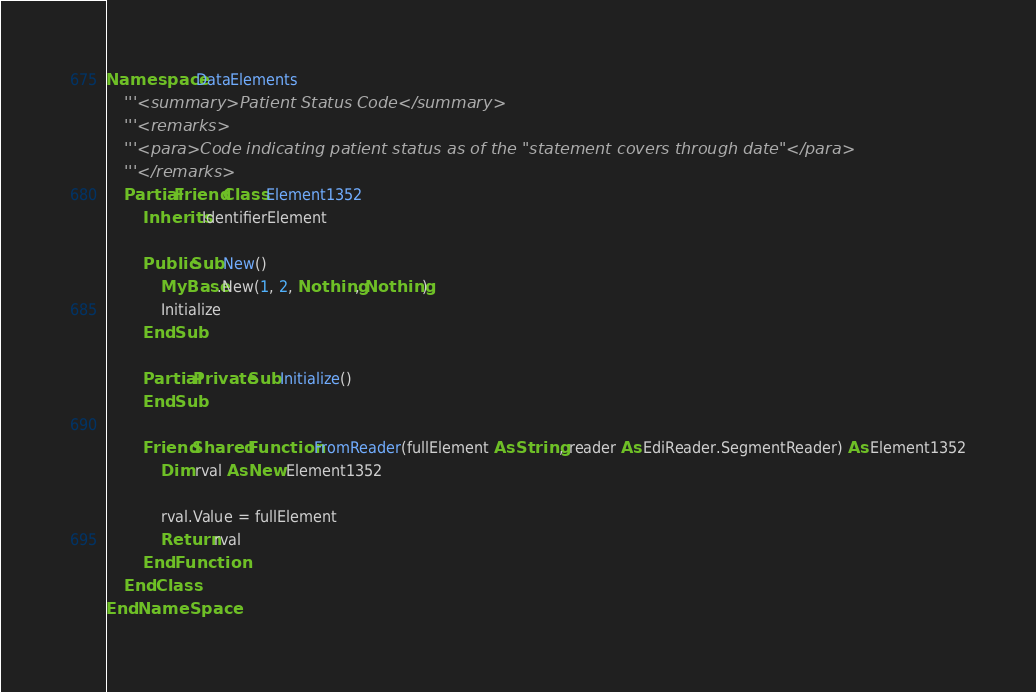Convert code to text. <code><loc_0><loc_0><loc_500><loc_500><_VisualBasic_>Namespace DataElements
    '''<summary>Patient Status Code</summary>
    '''<remarks>
    '''<para>Code indicating patient status as of the "statement covers through date"</para>
    '''</remarks>
    Partial Friend Class Element1352
        Inherits IdentifierElement

        Public Sub New()
            MyBase.New(1, 2, Nothing, Nothing)
            Initialize
        End Sub

        Partial Private Sub Initialize()
        End Sub

        Friend Shared Function FromReader(fullElement As String, reader As EdiReader.SegmentReader) As Element1352
            Dim rval As New Element1352

            rval.Value = fullElement
            Return rval
        End Function
    End Class
End NameSpace</code> 